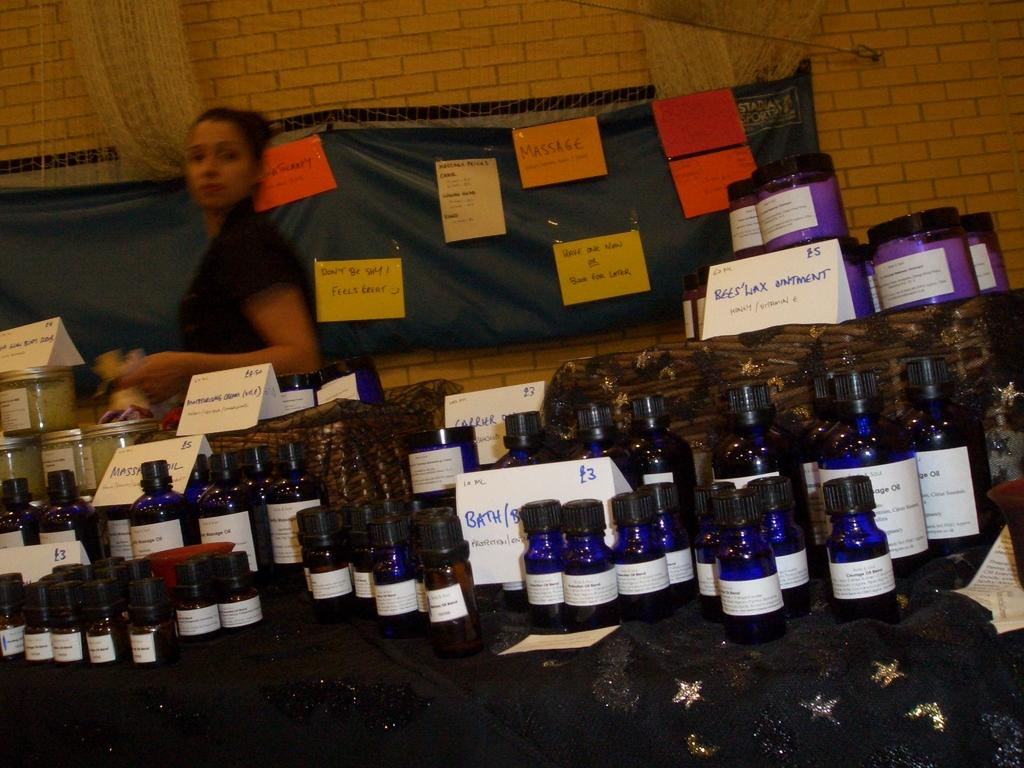<image>
Describe the image concisely. A table full of jars of products in front of a banner with signs for things like massage. 